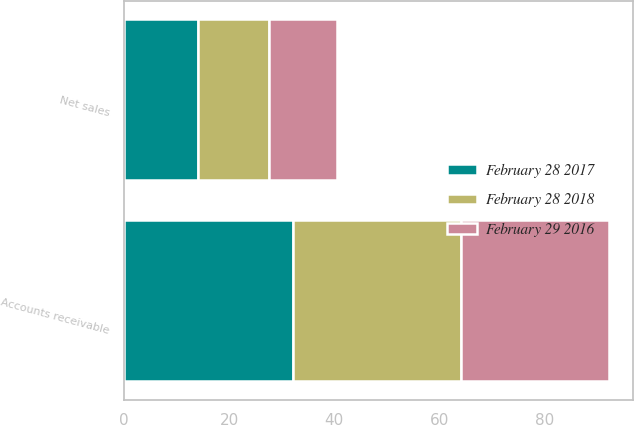Convert chart to OTSL. <chart><loc_0><loc_0><loc_500><loc_500><stacked_bar_chart><ecel><fcel>Net sales<fcel>Accounts receivable<nl><fcel>February 29 2016<fcel>13<fcel>28.1<nl><fcel>February 28 2017<fcel>14.1<fcel>32.1<nl><fcel>February 28 2018<fcel>13.4<fcel>32<nl></chart> 